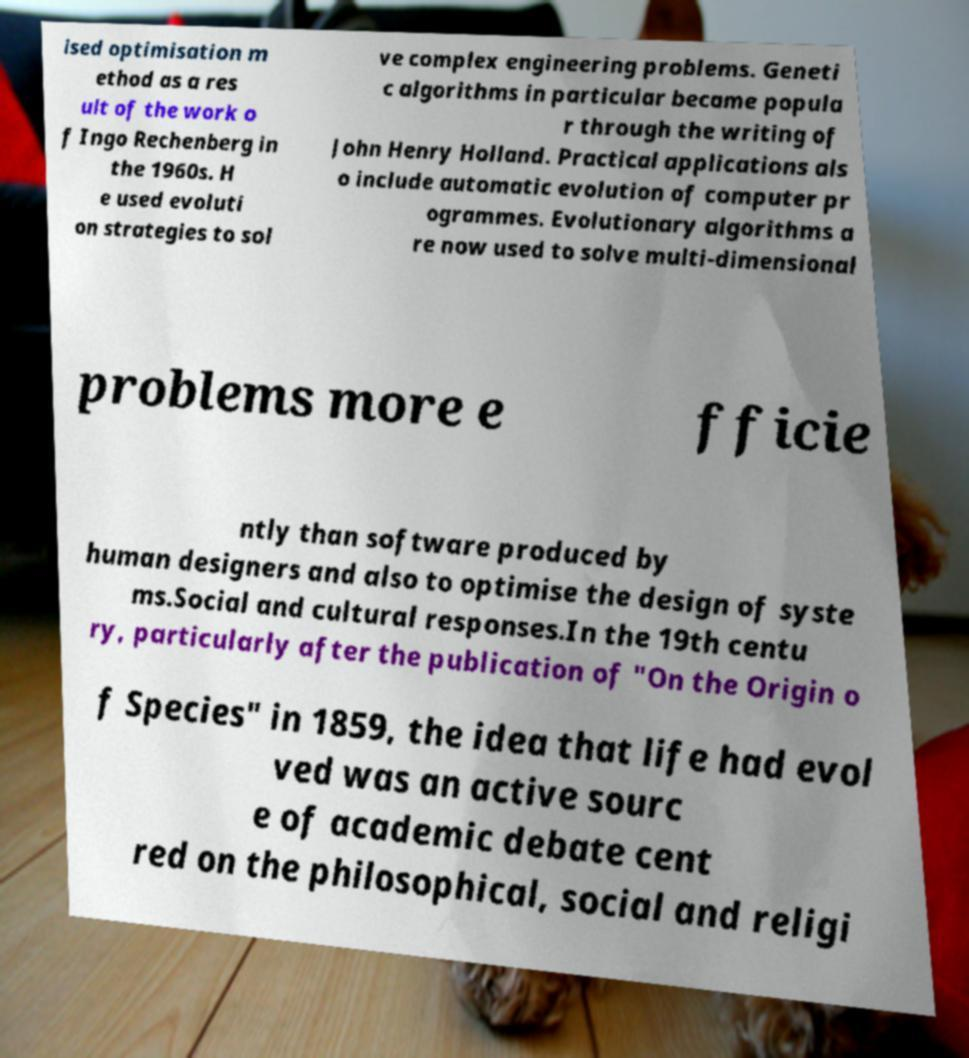I need the written content from this picture converted into text. Can you do that? ised optimisation m ethod as a res ult of the work o f Ingo Rechenberg in the 1960s. H e used evoluti on strategies to sol ve complex engineering problems. Geneti c algorithms in particular became popula r through the writing of John Henry Holland. Practical applications als o include automatic evolution of computer pr ogrammes. Evolutionary algorithms a re now used to solve multi-dimensional problems more e fficie ntly than software produced by human designers and also to optimise the design of syste ms.Social and cultural responses.In the 19th centu ry, particularly after the publication of "On the Origin o f Species" in 1859, the idea that life had evol ved was an active sourc e of academic debate cent red on the philosophical, social and religi 